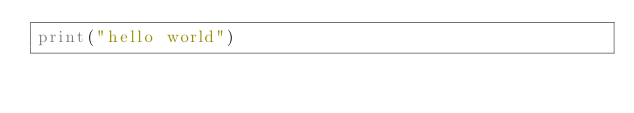Convert code to text. <code><loc_0><loc_0><loc_500><loc_500><_Python_>print("hello world")
</code> 